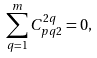Convert formula to latex. <formula><loc_0><loc_0><loc_500><loc_500>\sum _ { q = 1 } ^ { m } C _ { p q 2 } ^ { 2 q } = 0 ,</formula> 